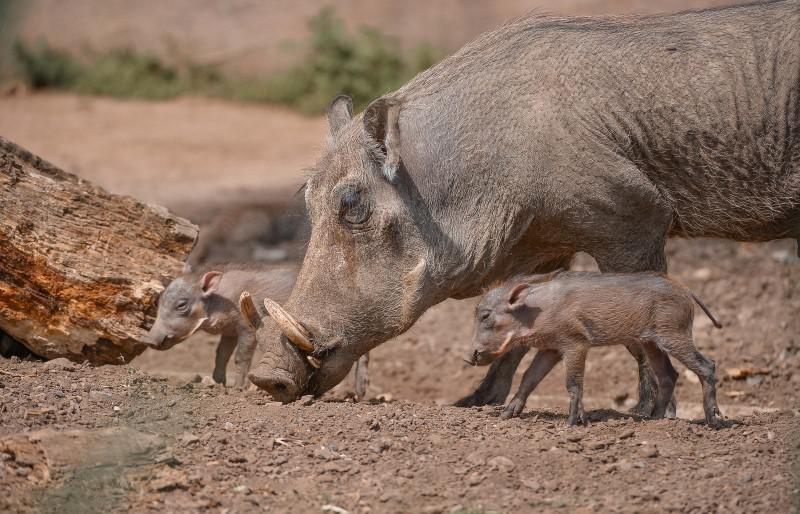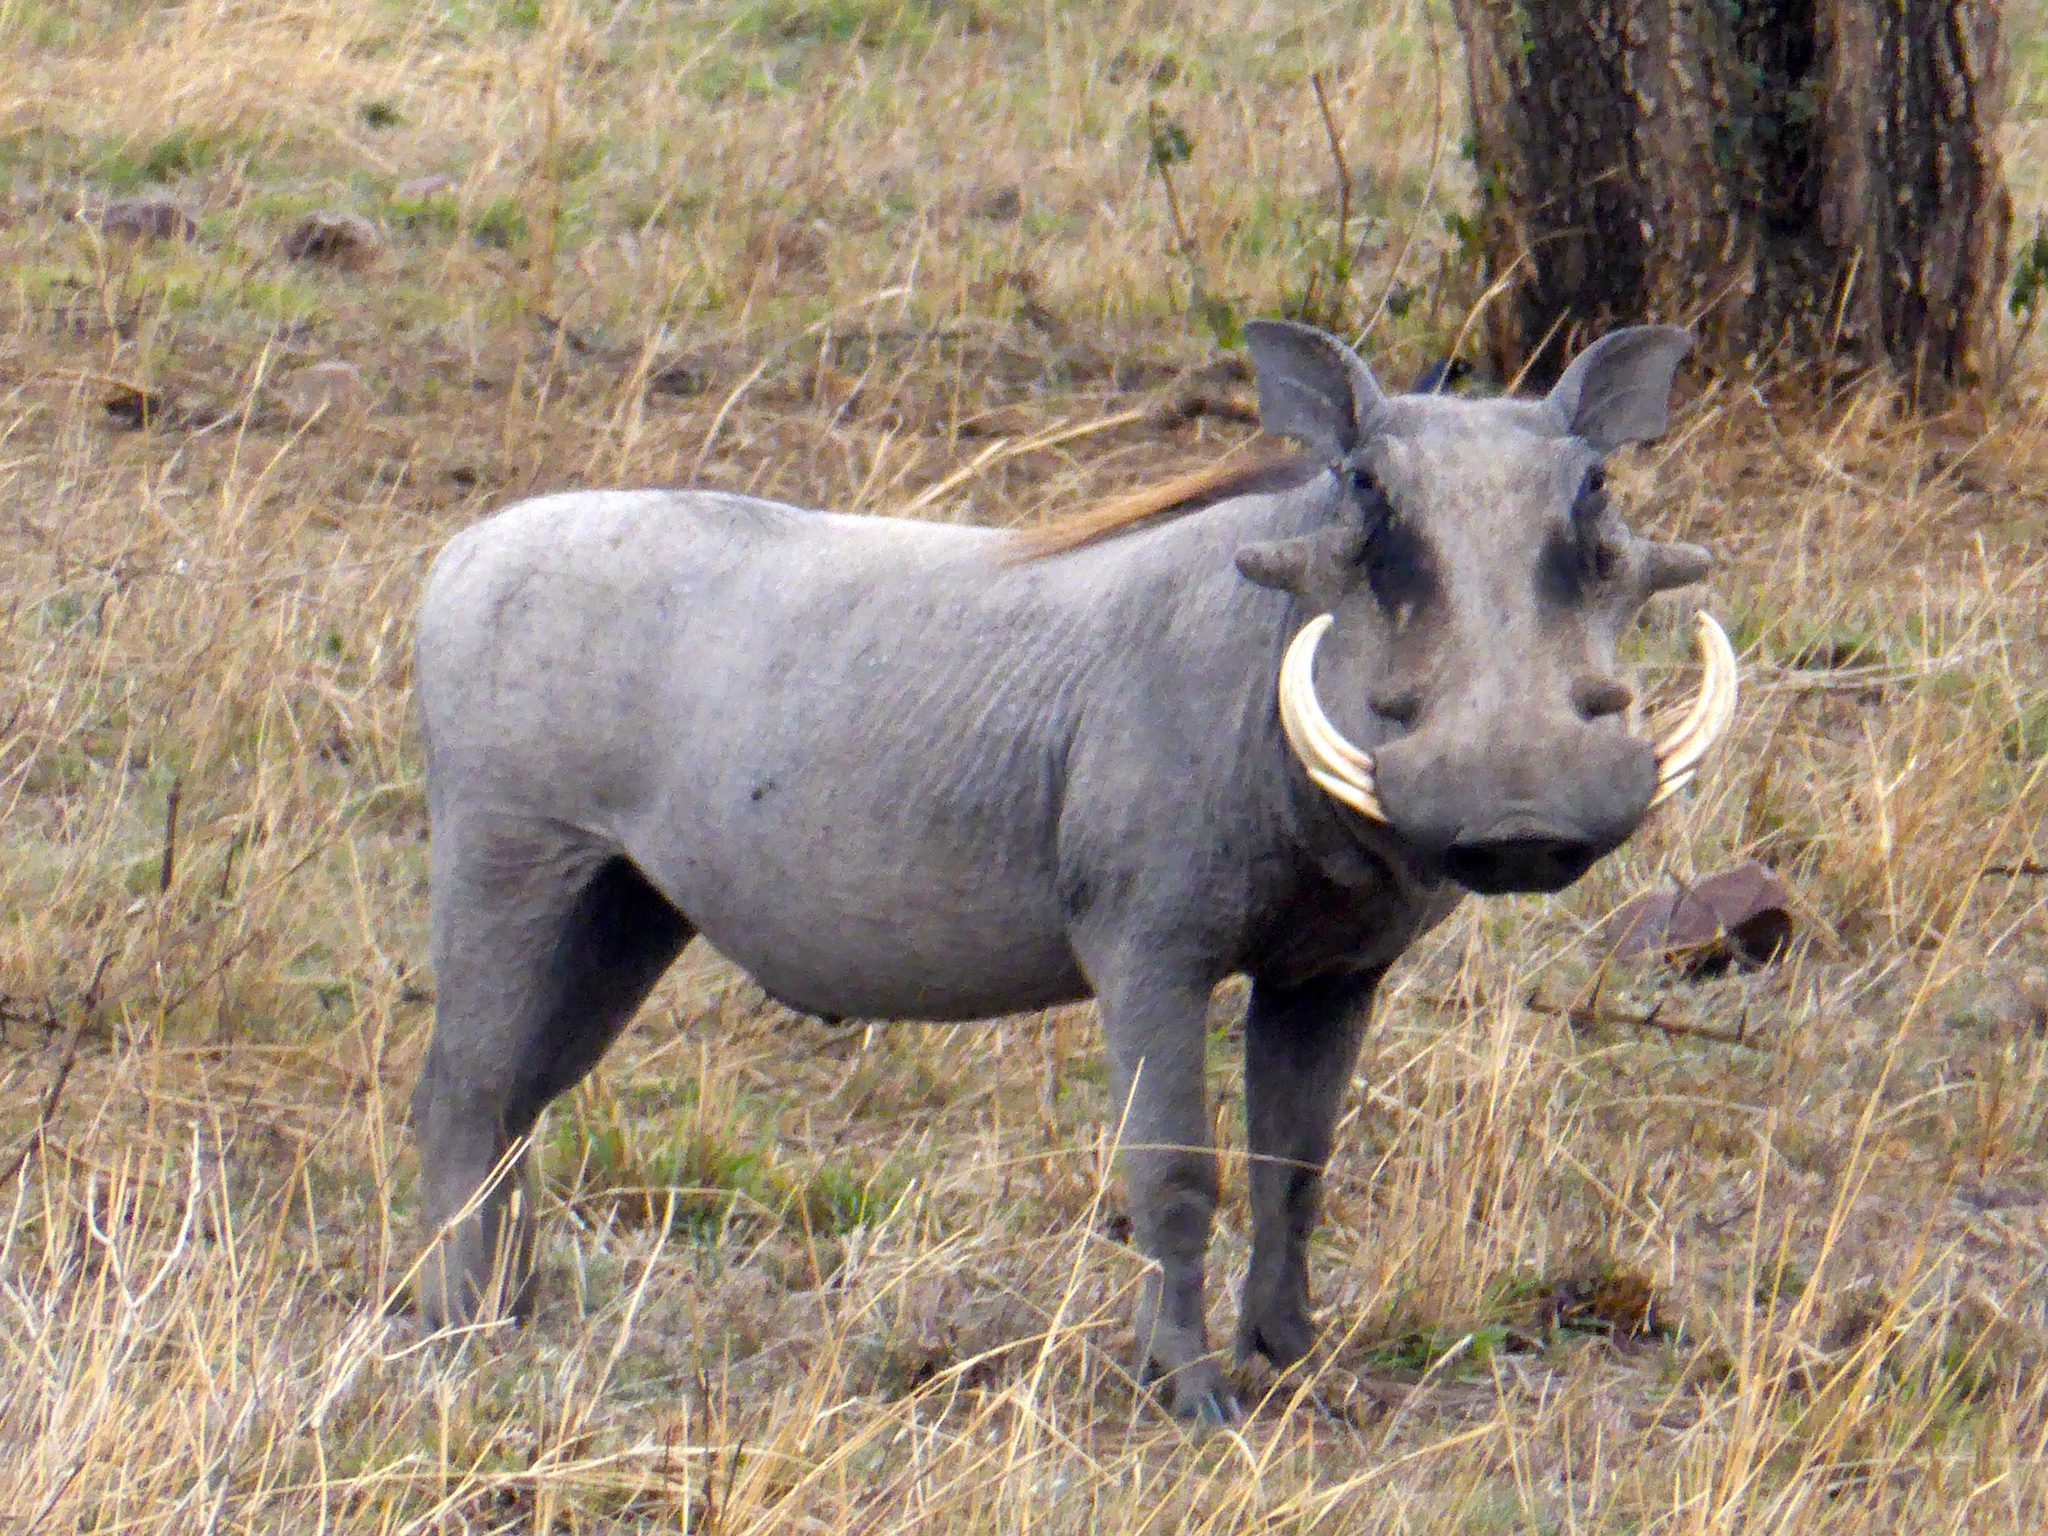The first image is the image on the left, the second image is the image on the right. Evaluate the accuracy of this statement regarding the images: "An image with a row of at least three warthogs includes at least one that looks straight at the camera.". Is it true? Answer yes or no. No. 